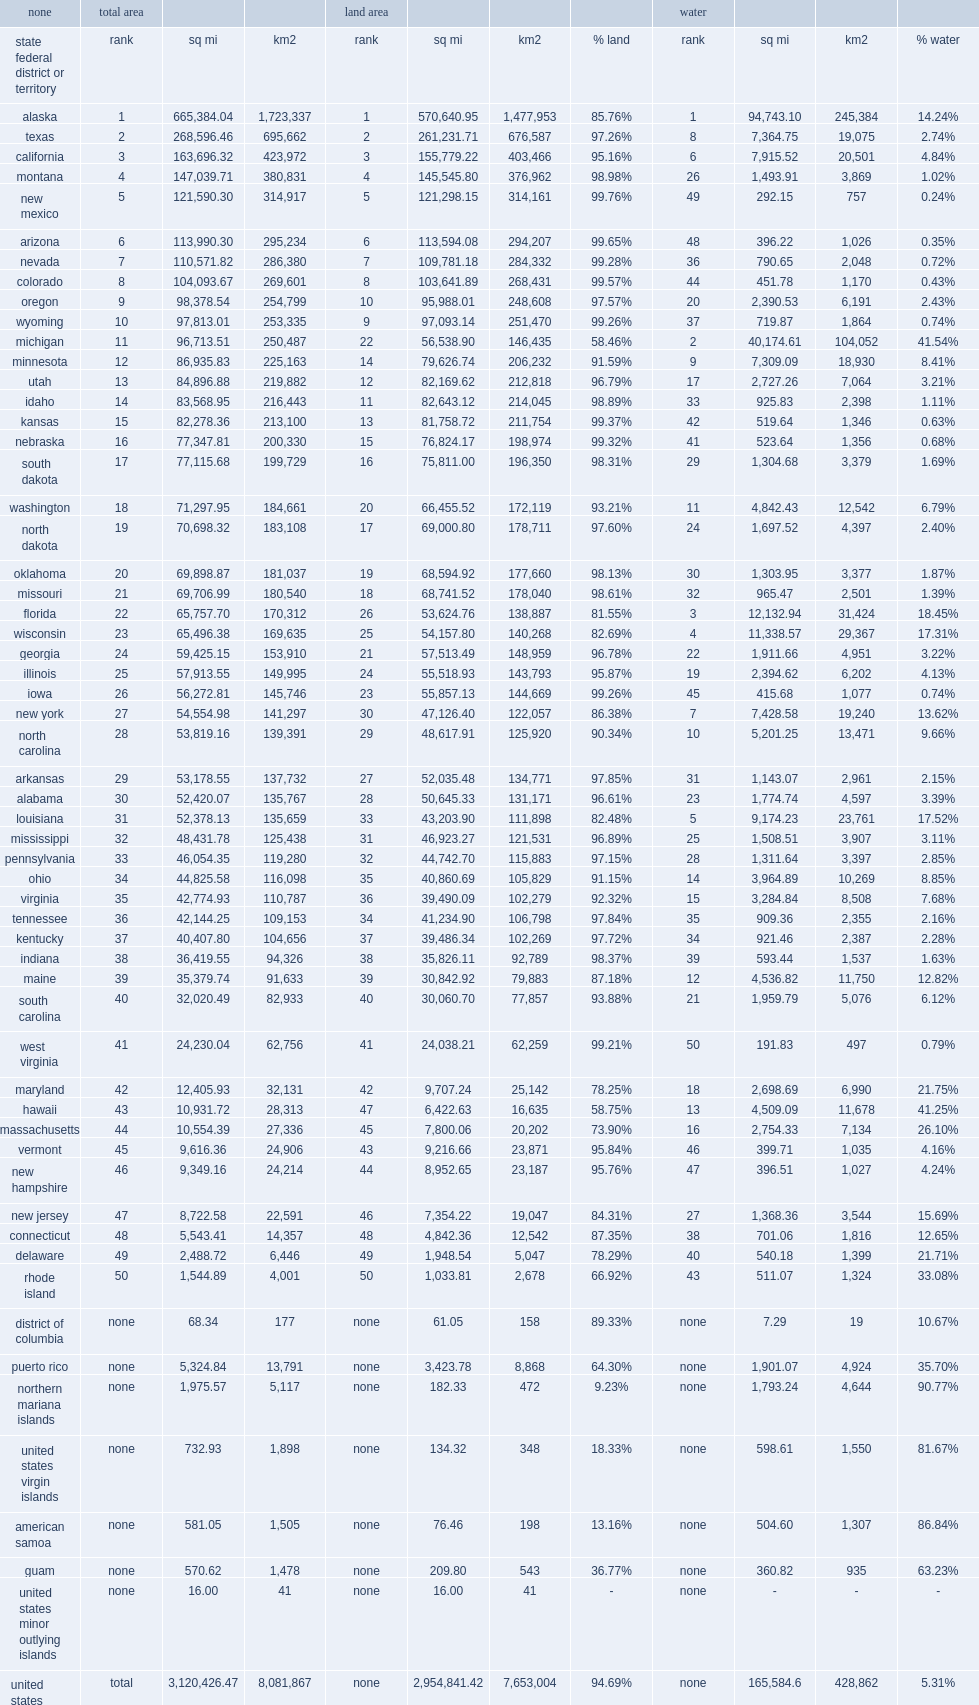What was the rank of wisconsin? 23.0. 